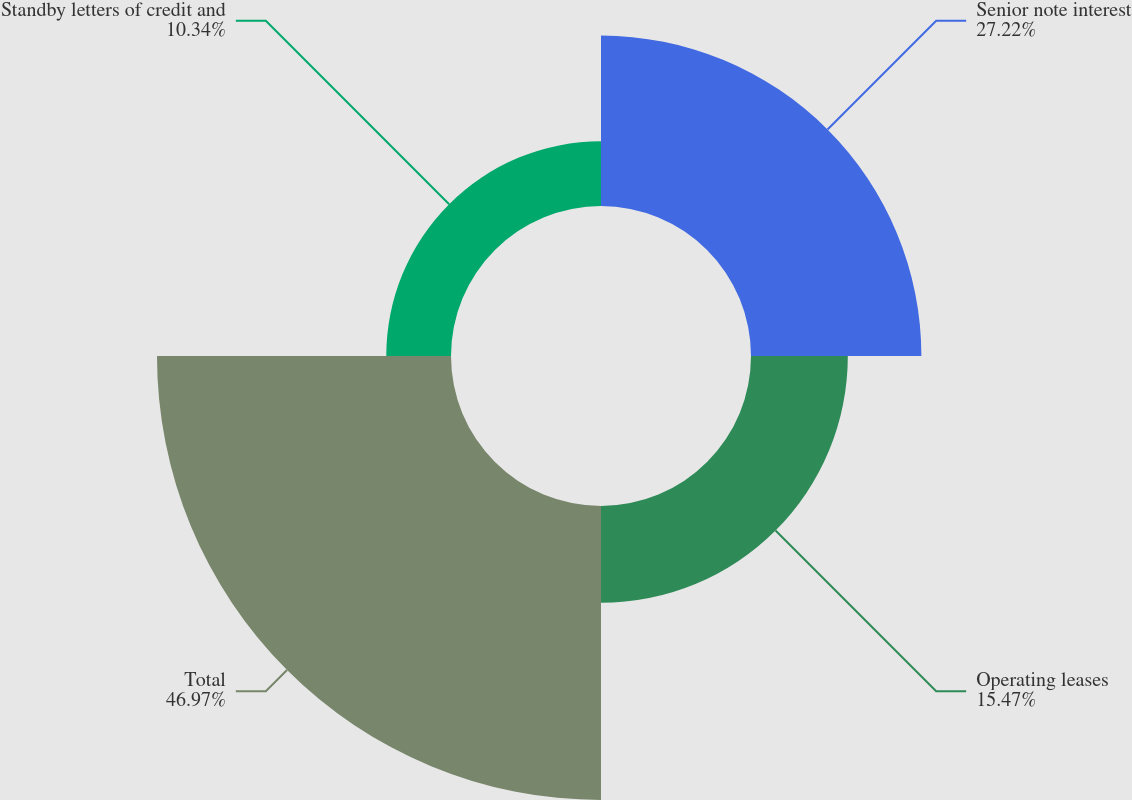<chart> <loc_0><loc_0><loc_500><loc_500><pie_chart><fcel>Senior note interest<fcel>Operating leases<fcel>Total<fcel>Standby letters of credit and<nl><fcel>27.22%<fcel>15.47%<fcel>46.97%<fcel>10.34%<nl></chart> 